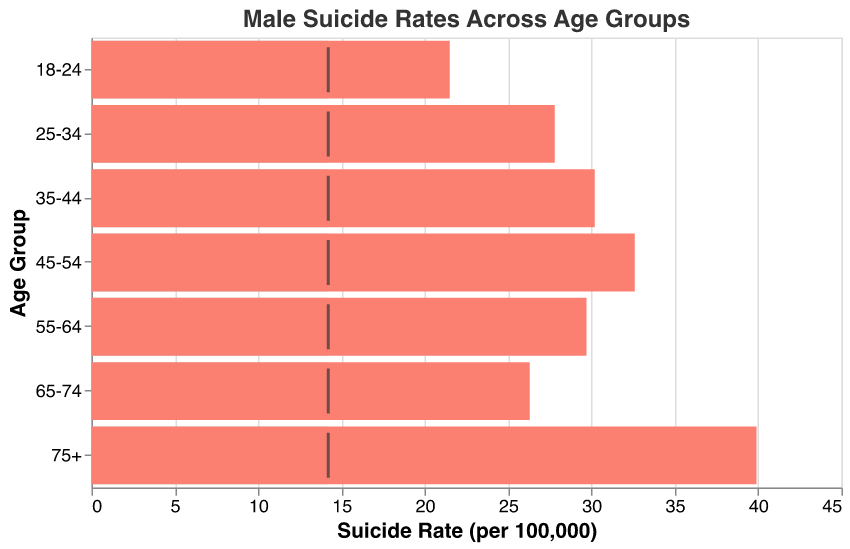What's the title of the chart? The title is at the top of the chart and reads "Male Suicide Rates Across Age Groups".
Answer: Male Suicide Rates Across Age Groups How many age groups are represented in the chart? By counting the number of distinct age groups on the y-axis, we can see there are seven age groups.
Answer: Seven Which age group has the highest male suicide rate? By looking at the bar heights and values on the x-axis, we can see that the '75+' age group has the highest suicide rate.
Answer: 75+ How does the suicide rate for the 45-54 age group compare to the national average? The bar for the '45-54' age group extends up to 32.6, which is compared against the national average tick at 14.2. The '45-54' rate is higher.
Answer: Higher What is the suicide rate for the 35-44 age group? The bar corresponding to the '35-44' age group extends to an x-axis value of 30.2.
Answer: 30.2 How much higher is the suicide rate for the 25-34 age group compared to the national average? The suicide rate for the '25-34' age group is 27.8. Subtract the national average, 14.2, from this value to find the difference: 27.8 - 14.2 = 13.6.
Answer: 13.6 Which age group has the smallest difference between its suicide rate and the national average? Compare the differences between each age group's suicide rate and the national average by subtracting 14.2 from each rate. The '18-24' age group has the smallest difference: 21.5 - 14.2 = 7.3.
Answer: 18-24 What is the average suicide rate for males in the 18-44 age range? Calculate the average by adding the suicide rates for the age groups '18-24', '25-34', and '35-44' and then dividing by 3: (21.5 + 27.8 + 30.2) / 3 = 26.5.
Answer: 26.5 What is the total difference in suicide rates between the oldest and youngest age groups compared to the national average? The '75+' age group has a suicide rate of 39.9 and '18-24' age group has 21.5. The differences from the national average are 39.9 - 14.2 = 25.7 and 21.5 - 14.2 = 7.3. Sum these differences for the total: 25.7 + 7.3 = 33.
Answer: 33 Is there any age group with a suicide rate lower than the national average? By comparing all the age group rates to the national average of 14.2, we can see that all age groups have rates higher than the national average.
Answer: No 